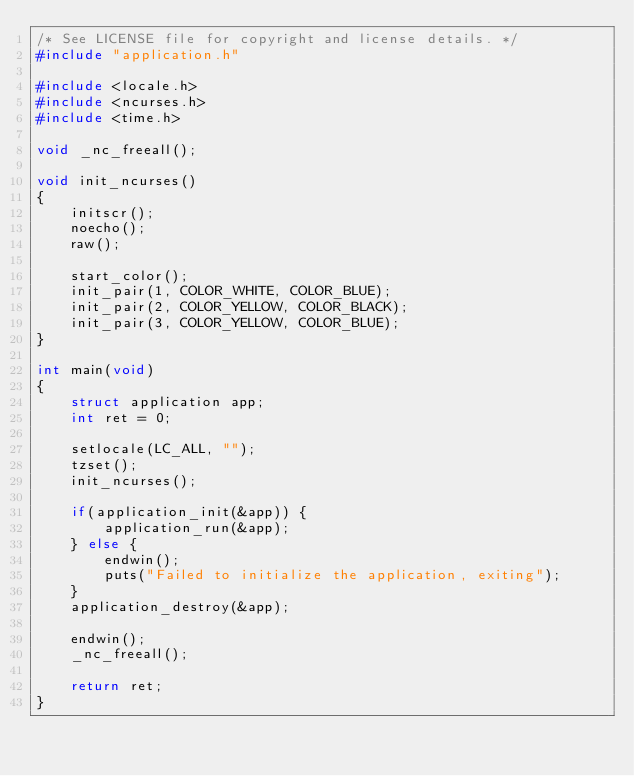Convert code to text. <code><loc_0><loc_0><loc_500><loc_500><_C_>/* See LICENSE file for copyright and license details. */
#include "application.h"

#include <locale.h>
#include <ncurses.h>
#include <time.h>

void _nc_freeall();

void init_ncurses()
{
	initscr();
	noecho();
	raw();

	start_color();
	init_pair(1, COLOR_WHITE, COLOR_BLUE);
	init_pair(2, COLOR_YELLOW, COLOR_BLACK);
	init_pair(3, COLOR_YELLOW, COLOR_BLUE);
}

int main(void)
{
	struct application app;
	int ret = 0;

	setlocale(LC_ALL, "");
	tzset();
	init_ncurses();

	if(application_init(&app)) {
		application_run(&app);
	} else {
		endwin();
		puts("Failed to initialize the application, exiting");
	}
	application_destroy(&app);

	endwin();
	_nc_freeall();

	return ret;
}
</code> 